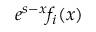Convert formula to latex. <formula><loc_0><loc_0><loc_500><loc_500>e ^ { s - x } f _ { i } ( x )</formula> 